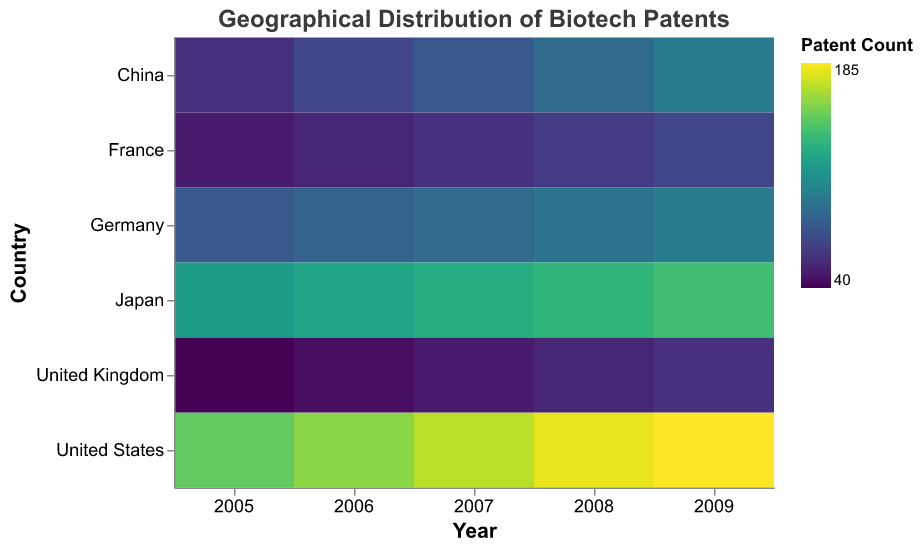What is the title of the heatmap? The title is usually displayed at the top of the figure and describes what the figure represents. In this case, it provides insight into the distribution of biotech patents geographically.
Answer: Geographical Distribution of Biotech Patents Which country had the highest number of biotech patents in 2007? To find this information, look at the column corresponding to the year 2007 and identify the country with the darkest-colored cell, indicating the highest patent count.
Answer: United States How does the number of biotech patents in Japan change from 2005 to 2009? Observe the cells in the row for Japan from 2005 to 2009. Look for changes in the cell color from left to right, which indicates changes in patent count.
Answer: It increases Which country had fewer biotech patents in 2008: France or the United Kingdom? Compare the colors of the cells in the 2008 column for France and the United Kingdom. The lighter the color, the fewer the patents.
Answer: United Kingdom What is the sum of biotech patents in Germany from 2005 to 2009? Add the patent counts for Germany for each year from 2005 to 2009: 80 + 85 + 90 + 95 + 100.
Answer: 450 Which year shows the highest total number of biotech patents across all countries? Sum the patent counts for each year and compare the totals to find the highest. Sum the values for 2005: (150+80+120+60+50+40), 2006: (160+85+125+70+55+45), 2007: (170+90+130+80+60+50), 2008: (180+95+135+90+65+55), 2009: (185+100+140+100+70+60). The year with the highest sum is 2009.
Answer: 2009 Which country shows the most consistent growth in biotech patents from 2005 to 2009? Examine the cells for each country from 2005 to 2009 and see which country shows a smooth, regular increase in patent counts, indicated by a consistent darkening of the cell color.
Answer: United States How does China’s patent count in 2008 compare to its count in 2005? Look at the cells for China for the years 2008 and 2005 and compare the colors. A darker color in 2008 compared to 2005 indicates an increase in patent count.
Answer: It increased Which country had fewer than 100 biotech patents in every year from 2005 to 2009? Find rows for countries where all cell colors are consistently light, indicating fewer than 100 patents each year.
Answer: France, United Kingdom Is the overall trend in biotech patents increasing, decreasing, or stable from 2005 to 2009? By examining the heatmap as a whole and noting the general color shift from left to right across all countries, you can determine if there is a trend of increasing, decreasing, or stable patent counts.
Answer: Increasing 